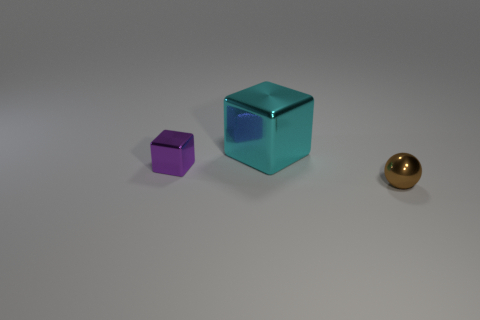Are there more things on the left side of the metal ball than big metallic cubes?
Make the answer very short. Yes. Is the material of the cyan cube the same as the small block?
Your response must be concise. Yes. What number of objects are either shiny blocks to the left of the big cyan metallic block or brown objects?
Offer a very short reply. 2. How many other things are the same size as the cyan cube?
Provide a short and direct response. 0. Are there the same number of small metal cubes on the right side of the cyan thing and large cyan blocks that are in front of the small brown sphere?
Make the answer very short. Yes. What is the color of the other shiny object that is the same shape as the big thing?
Make the answer very short. Purple. Are there any other things that are the same shape as the brown object?
Your response must be concise. No. The other object that is the same shape as the large cyan shiny thing is what size?
Ensure brevity in your answer.  Small. How many things have the same material as the tiny cube?
Provide a succinct answer. 2. There is a cube to the right of the cube that is on the left side of the cyan cube; are there any tiny metallic things that are behind it?
Offer a very short reply. No. 